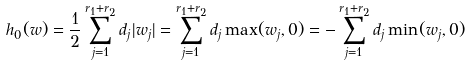Convert formula to latex. <formula><loc_0><loc_0><loc_500><loc_500>h _ { 0 } ( w ) = \frac { 1 } { 2 } \sum _ { j = 1 } ^ { r _ { 1 } + r _ { 2 } } d _ { j } | w _ { j } | = \sum _ { j = 1 } ^ { r _ { 1 } + r _ { 2 } } d _ { j } \max ( w _ { j } , 0 ) = - \sum _ { j = 1 } ^ { r _ { 1 } + r _ { 2 } } d _ { j } \min ( w _ { j } , 0 )</formula> 